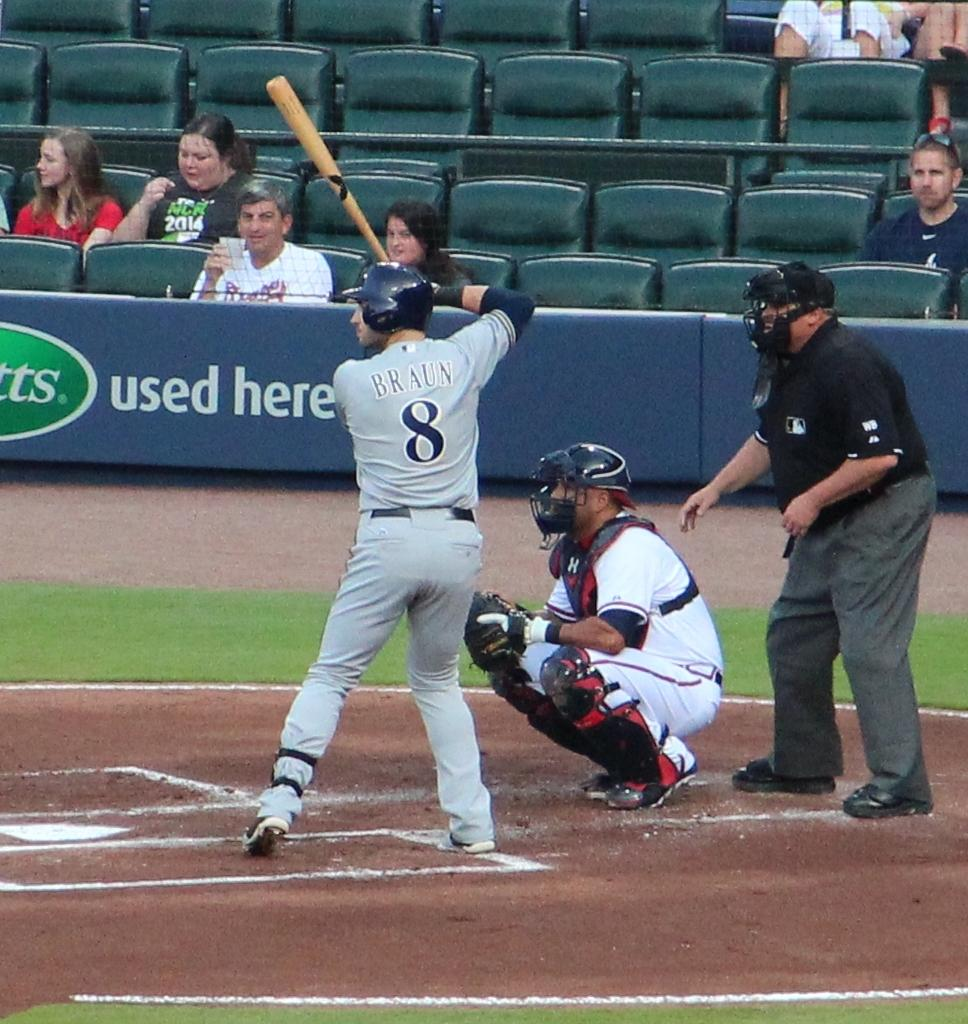<image>
Share a concise interpretation of the image provided. A batter has the name Braun on the back of his jersey. 